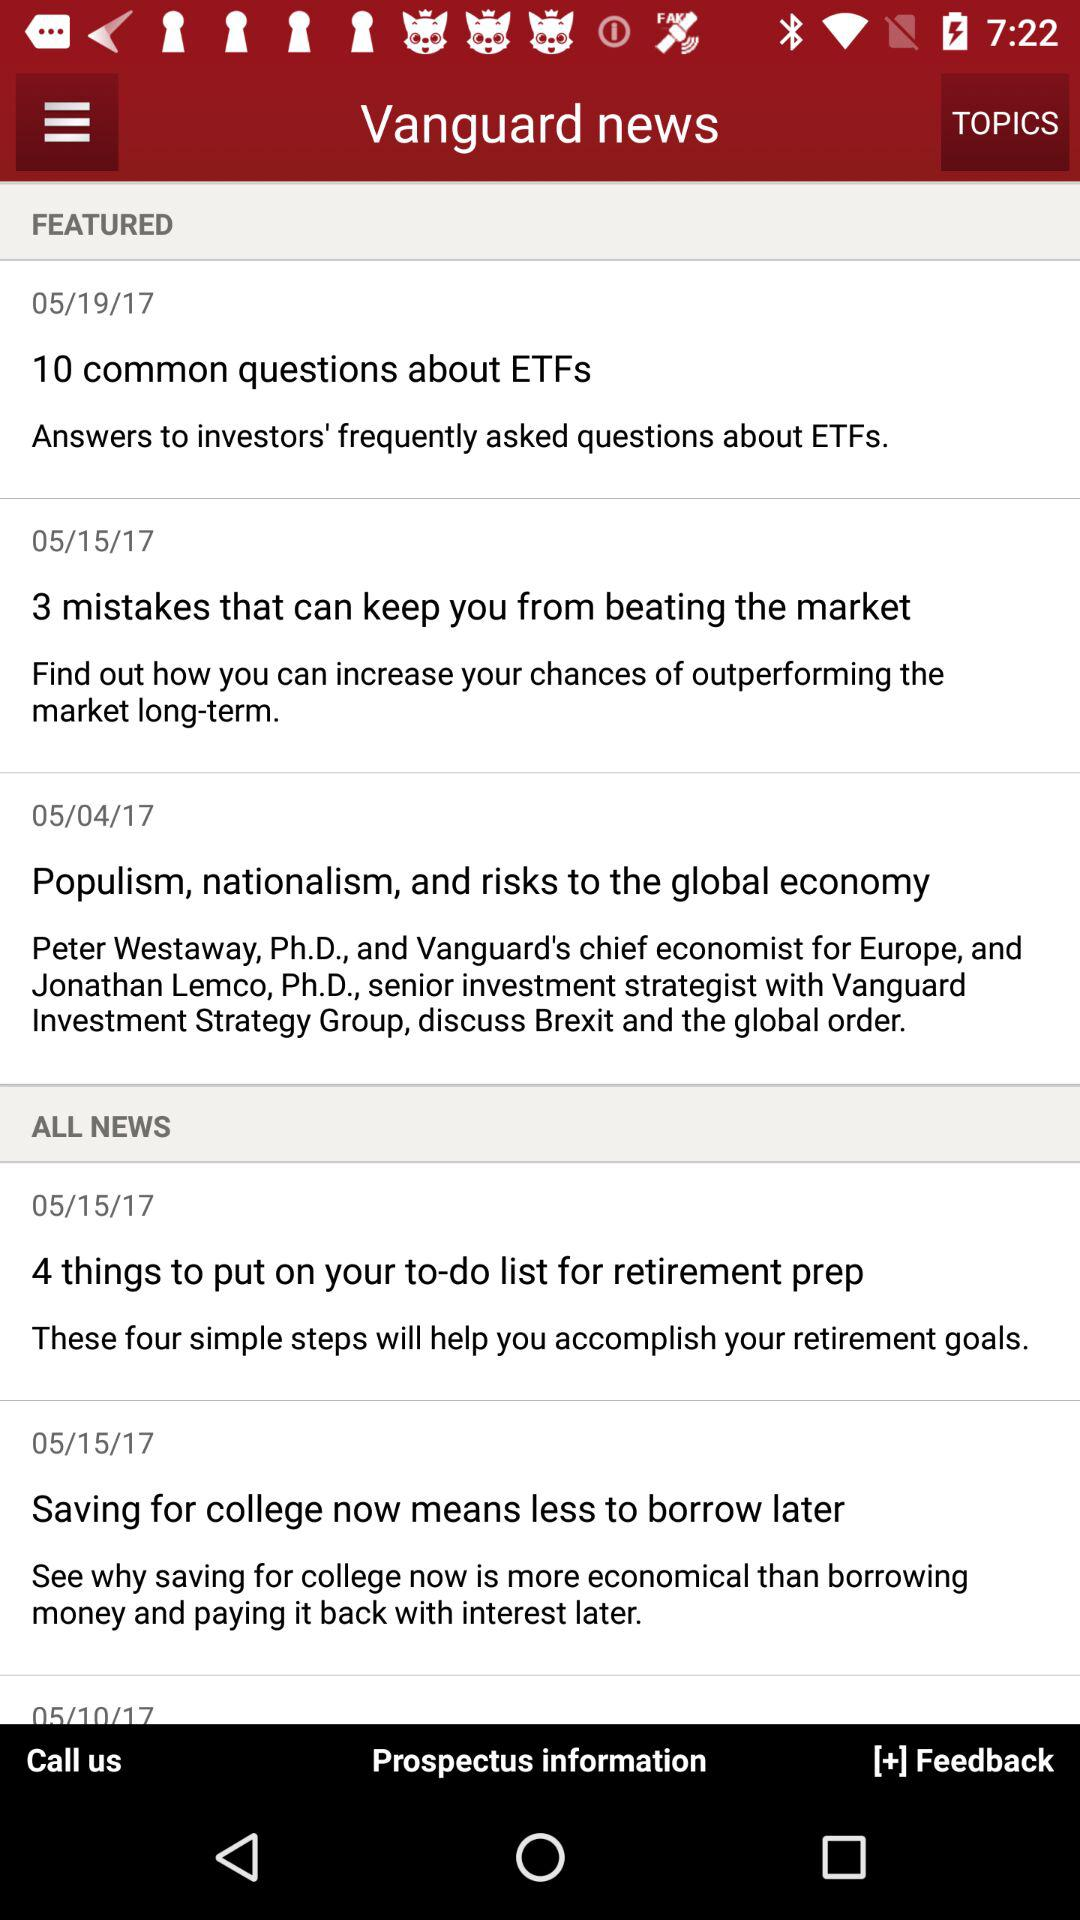On which date was the news "Saving for college now means less to borrow later" published? The news "Saving for college now means less to borrow later" was published on May 15, 2017. 